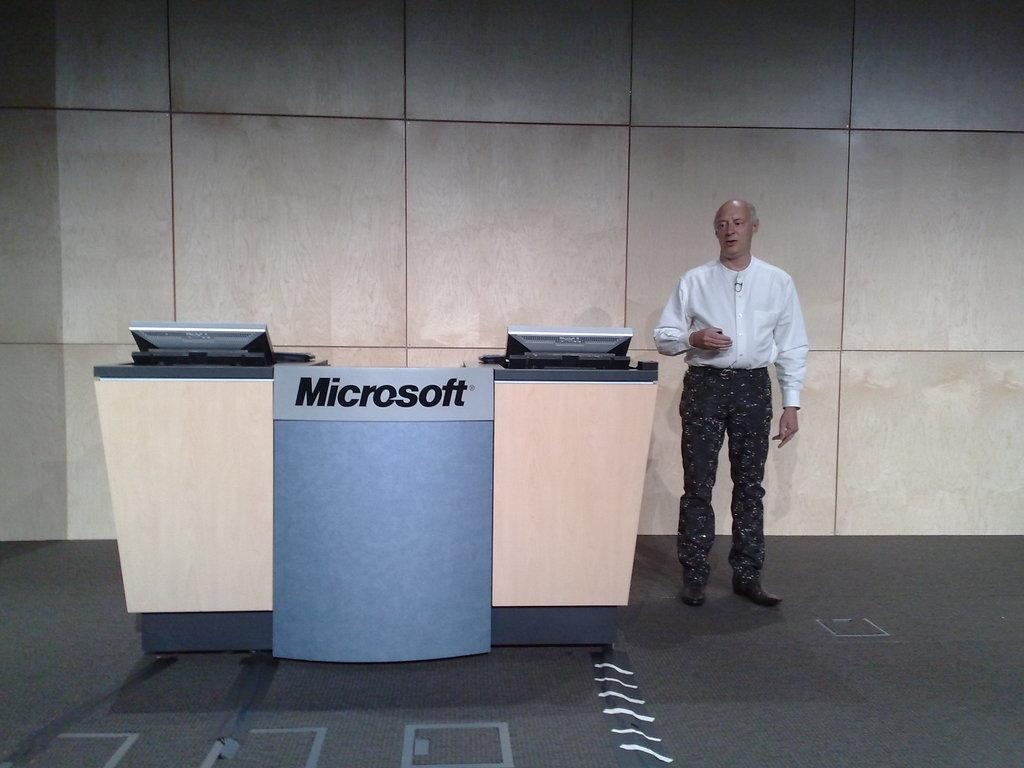<image>
Summarize the visual content of the image. A man stands next to a Microsoft desk in a lobby. 